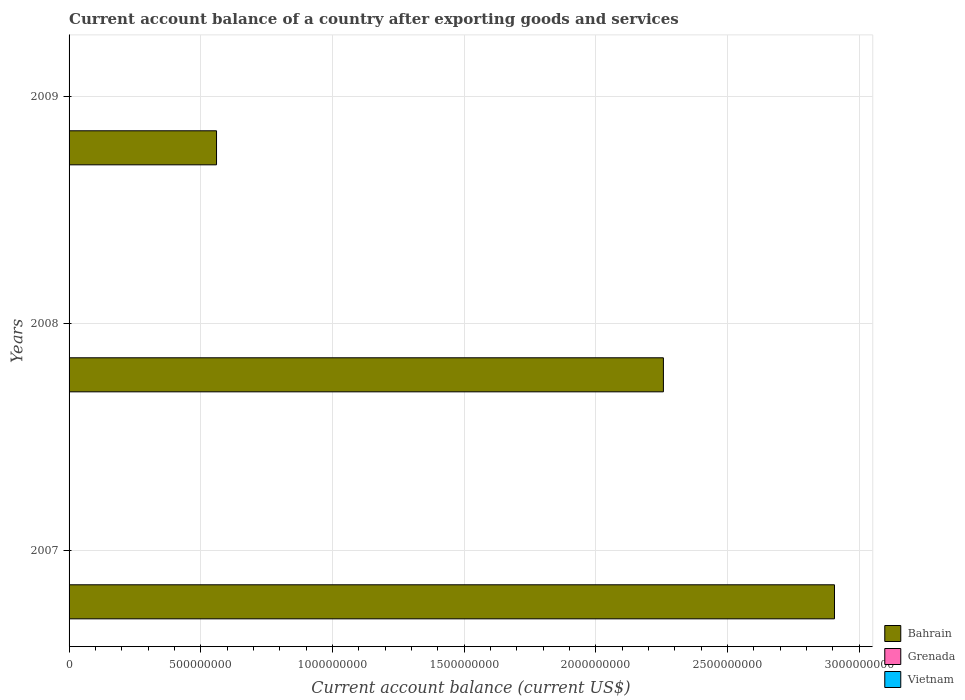How many different coloured bars are there?
Provide a succinct answer. 1. Are the number of bars per tick equal to the number of legend labels?
Offer a very short reply. No. Are the number of bars on each tick of the Y-axis equal?
Ensure brevity in your answer.  Yes. How many bars are there on the 3rd tick from the top?
Offer a very short reply. 1. What is the label of the 1st group of bars from the top?
Give a very brief answer. 2009. In how many cases, is the number of bars for a given year not equal to the number of legend labels?
Your response must be concise. 3. What is the account balance in Vietnam in 2008?
Make the answer very short. 0. Across all years, what is the maximum account balance in Bahrain?
Provide a succinct answer. 2.91e+09. Across all years, what is the minimum account balance in Vietnam?
Make the answer very short. 0. In which year was the account balance in Bahrain maximum?
Your response must be concise. 2007. What is the total account balance in Bahrain in the graph?
Offer a very short reply. 5.72e+09. What is the difference between the account balance in Bahrain in 2008 and that in 2009?
Offer a very short reply. 1.70e+09. What is the difference between the account balance in Bahrain in 2008 and the account balance in Grenada in 2007?
Offer a very short reply. 2.26e+09. What is the average account balance in Vietnam per year?
Offer a terse response. 0. In how many years, is the account balance in Vietnam greater than 1400000000 US$?
Keep it short and to the point. 0. What is the ratio of the account balance in Bahrain in 2007 to that in 2009?
Your answer should be very brief. 5.19. What is the difference between the highest and the second highest account balance in Bahrain?
Offer a terse response. 6.50e+08. What is the difference between the highest and the lowest account balance in Bahrain?
Your answer should be very brief. 2.35e+09. Is the sum of the account balance in Bahrain in 2007 and 2009 greater than the maximum account balance in Vietnam across all years?
Offer a very short reply. Yes. Is it the case that in every year, the sum of the account balance in Bahrain and account balance in Vietnam is greater than the account balance in Grenada?
Offer a very short reply. Yes. Are all the bars in the graph horizontal?
Your response must be concise. Yes. Does the graph contain any zero values?
Ensure brevity in your answer.  Yes. Where does the legend appear in the graph?
Provide a succinct answer. Bottom right. How many legend labels are there?
Give a very brief answer. 3. How are the legend labels stacked?
Offer a terse response. Vertical. What is the title of the graph?
Your answer should be very brief. Current account balance of a country after exporting goods and services. What is the label or title of the X-axis?
Keep it short and to the point. Current account balance (current US$). What is the Current account balance (current US$) in Bahrain in 2007?
Offer a terse response. 2.91e+09. What is the Current account balance (current US$) of Grenada in 2007?
Your answer should be compact. 0. What is the Current account balance (current US$) of Bahrain in 2008?
Offer a terse response. 2.26e+09. What is the Current account balance (current US$) in Grenada in 2008?
Provide a succinct answer. 0. What is the Current account balance (current US$) of Vietnam in 2008?
Your response must be concise. 0. What is the Current account balance (current US$) of Bahrain in 2009?
Give a very brief answer. 5.60e+08. What is the Current account balance (current US$) of Grenada in 2009?
Ensure brevity in your answer.  0. Across all years, what is the maximum Current account balance (current US$) of Bahrain?
Your answer should be compact. 2.91e+09. Across all years, what is the minimum Current account balance (current US$) in Bahrain?
Provide a succinct answer. 5.60e+08. What is the total Current account balance (current US$) in Bahrain in the graph?
Ensure brevity in your answer.  5.72e+09. What is the total Current account balance (current US$) of Grenada in the graph?
Your response must be concise. 0. What is the total Current account balance (current US$) of Vietnam in the graph?
Ensure brevity in your answer.  0. What is the difference between the Current account balance (current US$) in Bahrain in 2007 and that in 2008?
Your answer should be very brief. 6.50e+08. What is the difference between the Current account balance (current US$) in Bahrain in 2007 and that in 2009?
Provide a short and direct response. 2.35e+09. What is the difference between the Current account balance (current US$) in Bahrain in 2008 and that in 2009?
Ensure brevity in your answer.  1.70e+09. What is the average Current account balance (current US$) in Bahrain per year?
Give a very brief answer. 1.91e+09. What is the average Current account balance (current US$) of Grenada per year?
Make the answer very short. 0. What is the ratio of the Current account balance (current US$) in Bahrain in 2007 to that in 2008?
Keep it short and to the point. 1.29. What is the ratio of the Current account balance (current US$) in Bahrain in 2007 to that in 2009?
Your response must be concise. 5.19. What is the ratio of the Current account balance (current US$) of Bahrain in 2008 to that in 2009?
Keep it short and to the point. 4.03. What is the difference between the highest and the second highest Current account balance (current US$) in Bahrain?
Ensure brevity in your answer.  6.50e+08. What is the difference between the highest and the lowest Current account balance (current US$) of Bahrain?
Provide a succinct answer. 2.35e+09. 